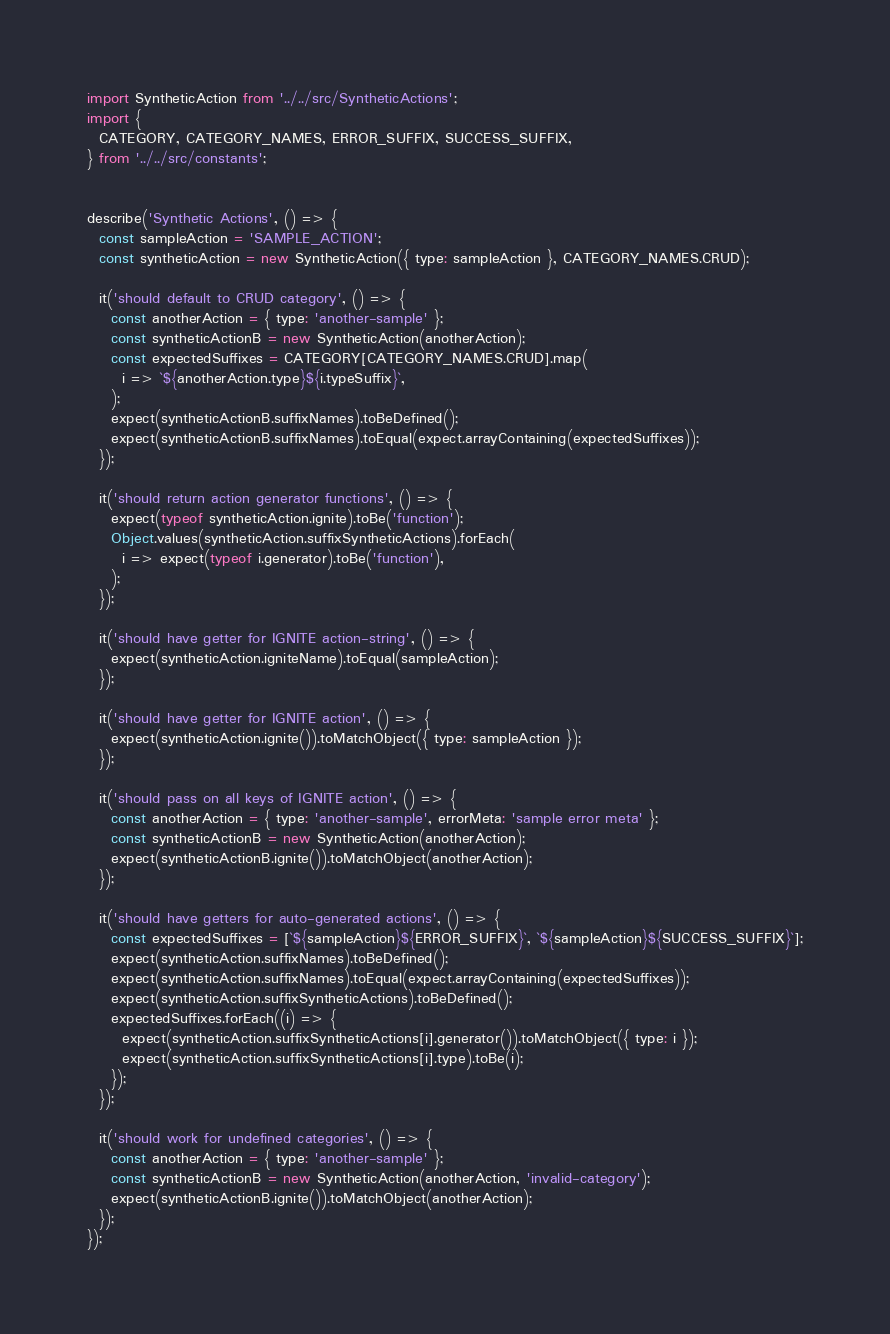Convert code to text. <code><loc_0><loc_0><loc_500><loc_500><_JavaScript_>import SyntheticAction from '../../src/SyntheticActions';
import {
  CATEGORY, CATEGORY_NAMES, ERROR_SUFFIX, SUCCESS_SUFFIX,
} from '../../src/constants';


describe('Synthetic Actions', () => {
  const sampleAction = 'SAMPLE_ACTION';
  const syntheticAction = new SyntheticAction({ type: sampleAction }, CATEGORY_NAMES.CRUD);

  it('should default to CRUD category', () => {
    const anotherAction = { type: 'another-sample' };
    const syntheticActionB = new SyntheticAction(anotherAction);
    const expectedSuffixes = CATEGORY[CATEGORY_NAMES.CRUD].map(
      i => `${anotherAction.type}${i.typeSuffix}`,
    );
    expect(syntheticActionB.suffixNames).toBeDefined();
    expect(syntheticActionB.suffixNames).toEqual(expect.arrayContaining(expectedSuffixes));
  });

  it('should return action generator functions', () => {
    expect(typeof syntheticAction.ignite).toBe('function');
    Object.values(syntheticAction.suffixSyntheticActions).forEach(
      i => expect(typeof i.generator).toBe('function'),
    );
  });

  it('should have getter for IGNITE action-string', () => {
    expect(syntheticAction.igniteName).toEqual(sampleAction);
  });

  it('should have getter for IGNITE action', () => {
    expect(syntheticAction.ignite()).toMatchObject({ type: sampleAction });
  });

  it('should pass on all keys of IGNITE action', () => {
    const anotherAction = { type: 'another-sample', errorMeta: 'sample error meta' };
    const syntheticActionB = new SyntheticAction(anotherAction);
    expect(syntheticActionB.ignite()).toMatchObject(anotherAction);
  });

  it('should have getters for auto-generated actions', () => {
    const expectedSuffixes = [`${sampleAction}${ERROR_SUFFIX}`, `${sampleAction}${SUCCESS_SUFFIX}`];
    expect(syntheticAction.suffixNames).toBeDefined();
    expect(syntheticAction.suffixNames).toEqual(expect.arrayContaining(expectedSuffixes));
    expect(syntheticAction.suffixSyntheticActions).toBeDefined();
    expectedSuffixes.forEach((i) => {
      expect(syntheticAction.suffixSyntheticActions[i].generator()).toMatchObject({ type: i });
      expect(syntheticAction.suffixSyntheticActions[i].type).toBe(i);
    });
  });

  it('should work for undefined categories', () => {
    const anotherAction = { type: 'another-sample' };
    const syntheticActionB = new SyntheticAction(anotherAction, 'invalid-category');
    expect(syntheticActionB.ignite()).toMatchObject(anotherAction);
  });
});
</code> 